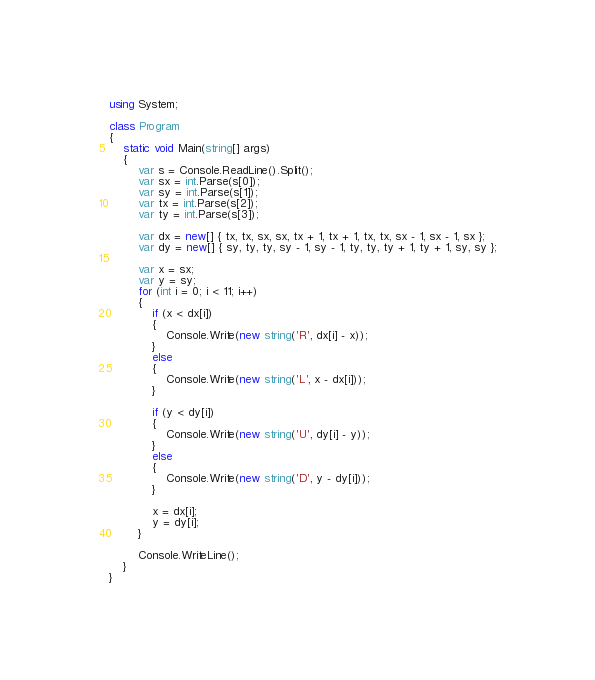<code> <loc_0><loc_0><loc_500><loc_500><_C#_>using System;

class Program
{
    static void Main(string[] args)
    {
        var s = Console.ReadLine().Split();
        var sx = int.Parse(s[0]);
        var sy = int.Parse(s[1]);
        var tx = int.Parse(s[2]);
        var ty = int.Parse(s[3]);

        var dx = new[] { tx, tx, sx, sx, tx + 1, tx + 1, tx, tx, sx - 1, sx - 1, sx };
        var dy = new[] { sy, ty, ty, sy - 1, sy - 1, ty, ty, ty + 1, ty + 1, sy, sy };

        var x = sx;
        var y = sy;
        for (int i = 0; i < 11; i++)
        {
            if (x < dx[i])
            {
                Console.Write(new string('R', dx[i] - x));
            }
            else
            {
                Console.Write(new string('L', x - dx[i]));
            }

            if (y < dy[i])
            {
                Console.Write(new string('U', dy[i] - y));
            }
            else
            {
                Console.Write(new string('D', y - dy[i]));
            }

            x = dx[i];
            y = dy[i];
        }

        Console.WriteLine();
    }
}
</code> 